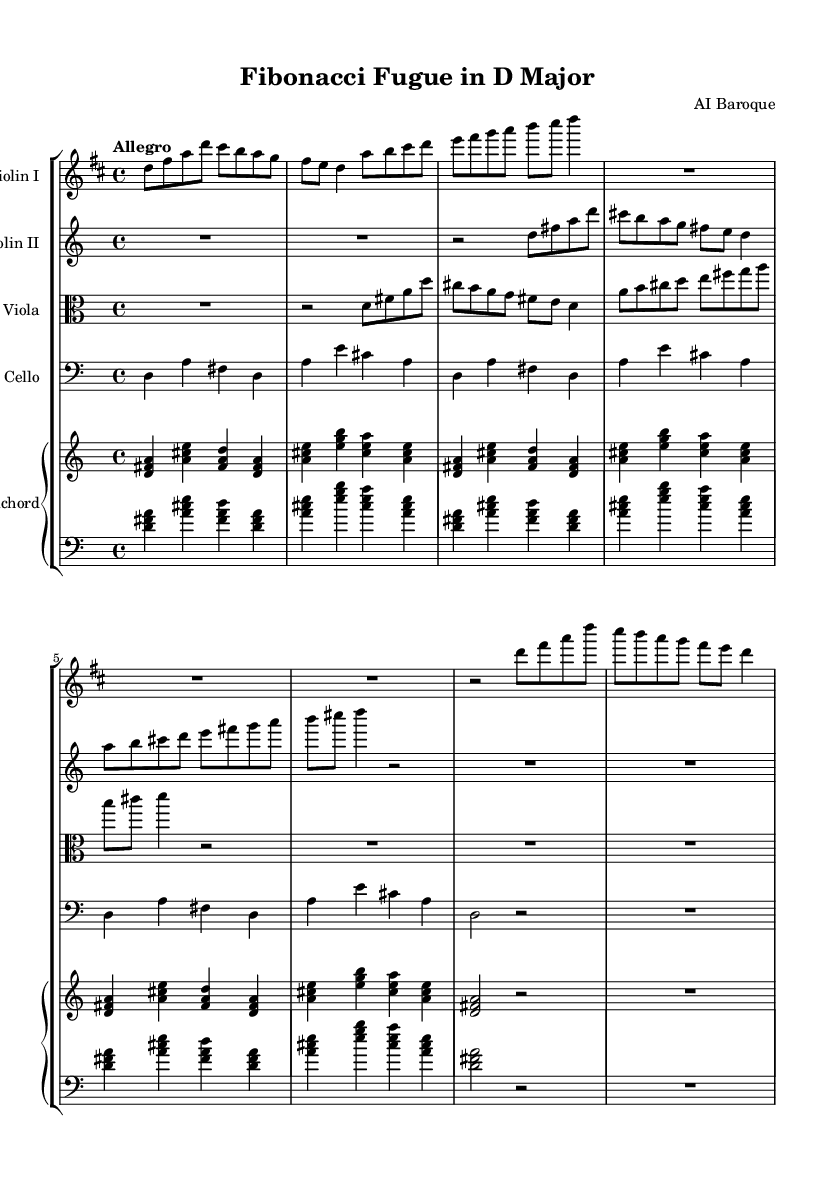What is the key signature of this music? The key signature is indicated at the beginning of the staff and shows two sharps (F# and C#), which is characteristic of D major.
Answer: D major What is the time signature of the piece? The time signature appears at the beginning of the score as 4/4, indicating four beats per measure with the quarter note receiving one beat.
Answer: 4/4 What is the tempo marking of the composition? The tempo marking is indicated above the staff as "Allegro," which indicates a fast and lively tempo.
Answer: Allegro How many measures are there in the violin I part? By counting the measures notated in the violin I staff, there are a total of 9 measures in the part shown.
Answer: 9 Which mathematical pattern is primarily reflected in the piece? The piece is referred to as the "Fibonacci Fugue," indicating that it likely uses Fibonacci sequences in its structure and progression.
Answer: Fibonacci How many instruments are scored for this piece? The score contains five parts: Violin I, Violin II, Viola, Cello, and Harpsichord, indicating a total of five instruments.
Answer: Five What form does this piece take? The term "Fugue" in the title suggests that the composition is structured in a polyphonic form, typically involving the imitation of a subject by other voices.
Answer: Fugue 